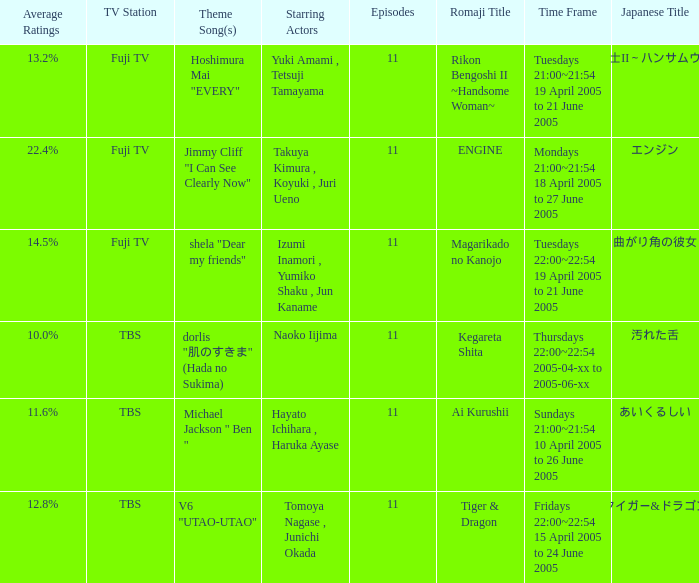Give me the full table as a dictionary. {'header': ['Average Ratings', 'TV Station', 'Theme Song(s)', 'Starring Actors', 'Episodes', 'Romaji Title', 'Time Frame', 'Japanese Title'], 'rows': [['13.2%', 'Fuji TV', 'Hoshimura Mai "EVERY"', 'Yuki Amami , Tetsuji Tamayama', '11', 'Rikon Bengoshi II ~Handsome Woman~', 'Tuesdays 21:00~21:54 19 April 2005 to 21 June 2005', '離婚弁護士II～ハンサムウーマン～'], ['22.4%', 'Fuji TV', 'Jimmy Cliff "I Can See Clearly Now"', 'Takuya Kimura , Koyuki , Juri Ueno', '11', 'ENGINE', 'Mondays 21:00~21:54 18 April 2005 to 27 June 2005', 'エンジン'], ['14.5%', 'Fuji TV', 'shela "Dear my friends"', 'Izumi Inamori , Yumiko Shaku , Jun Kaname', '11', 'Magarikado no Kanojo', 'Tuesdays 22:00~22:54 19 April 2005 to 21 June 2005', '曲がり角の彼女'], ['10.0%', 'TBS', 'dorlis "肌のすきま" (Hada no Sukima)', 'Naoko Iijima', '11', 'Kegareta Shita', 'Thursdays 22:00~22:54 2005-04-xx to 2005-06-xx', '汚れた舌'], ['11.6%', 'TBS', 'Michael Jackson " Ben "', 'Hayato Ichihara , Haruka Ayase', '11', 'Ai Kurushii', 'Sundays 21:00~21:54 10 April 2005 to 26 June 2005', 'あいくるしい'], ['12.8%', 'TBS', 'V6 "UTAO-UTAO"', 'Tomoya Nagase , Junichi Okada', '11', 'Tiger & Dragon', 'Fridays 22:00~22:54 15 April 2005 to 24 June 2005', 'タイガー&ドラゴン']]} What is the theme song for Magarikado no Kanojo? Shela "dear my friends". 